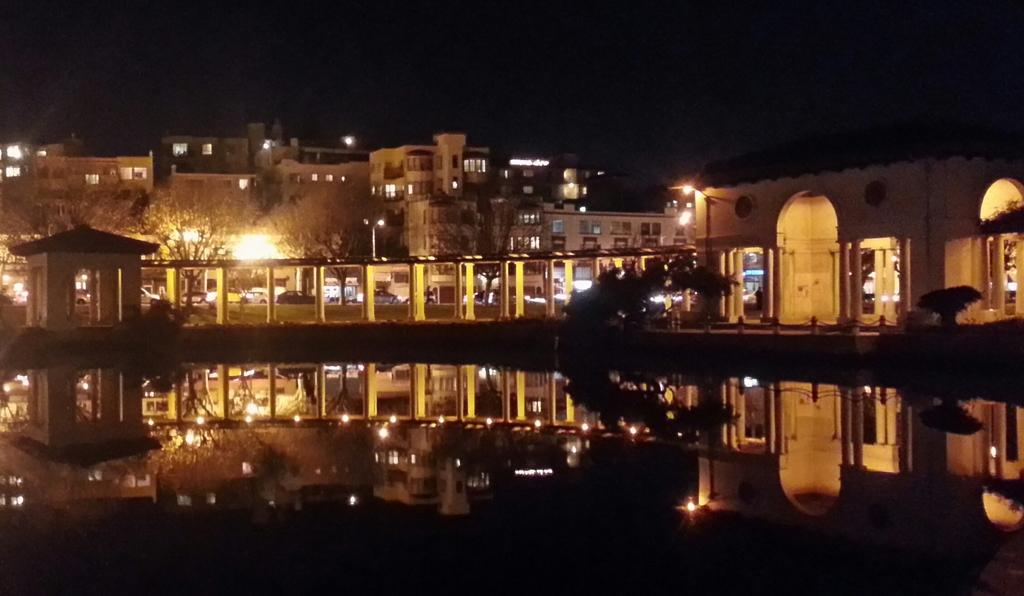What type of structures can be seen in the image? There are buildings in the image. What else is visible in the image besides the buildings? There are lights, trees, pillars, vehicles, and a reflection at the bottom of the image. Additionally, the sky is visible in the background of the image. Can you describe the lighting in the image? Yes, there are lights visible in the image. What architectural features can be seen in the image? There are pillars visible in the image. What type of vehicles are present in the image? The image contains vehicles, but the specific types cannot be determined from the provided facts. Who is the creator of the kick in the image? There is no kick present in the image, so it is not possible to determine who the creator might be. 